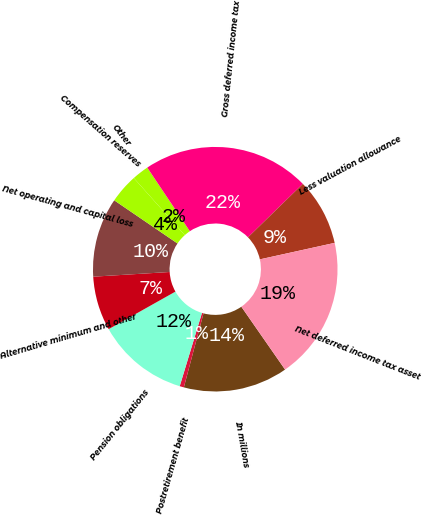Convert chart. <chart><loc_0><loc_0><loc_500><loc_500><pie_chart><fcel>In millions<fcel>Postretirement benefit<fcel>Pension obligations<fcel>Alternative minimum and other<fcel>Net operating and capital loss<fcel>Compensation reserves<fcel>Other<fcel>Gross deferred income tax<fcel>Less valuation allowance<fcel>Net deferred income tax asset<nl><fcel>13.81%<fcel>0.56%<fcel>12.15%<fcel>7.18%<fcel>10.5%<fcel>3.87%<fcel>2.22%<fcel>22.09%<fcel>8.84%<fcel>18.78%<nl></chart> 